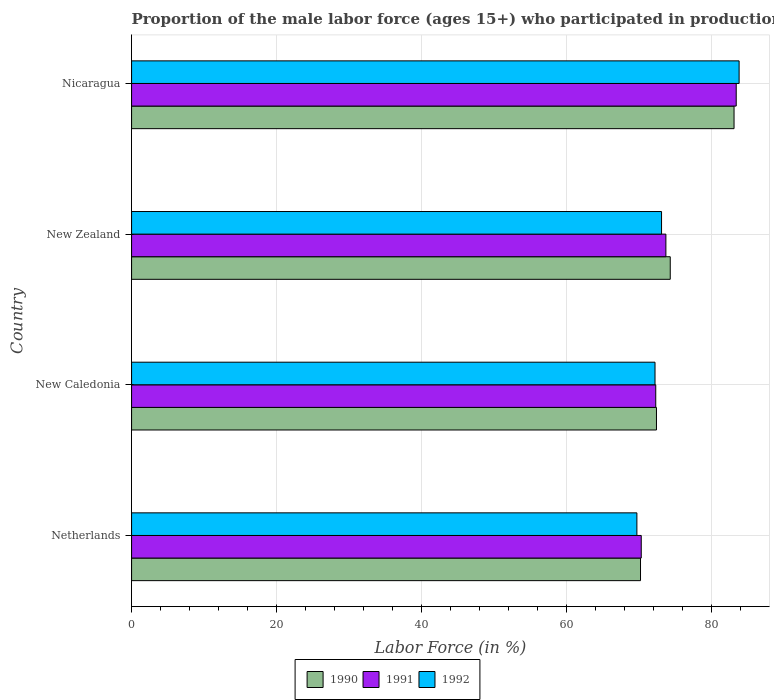How many different coloured bars are there?
Your answer should be very brief. 3. How many groups of bars are there?
Offer a very short reply. 4. Are the number of bars per tick equal to the number of legend labels?
Give a very brief answer. Yes. Are the number of bars on each tick of the Y-axis equal?
Provide a succinct answer. Yes. What is the label of the 2nd group of bars from the top?
Your answer should be very brief. New Zealand. What is the proportion of the male labor force who participated in production in 1992 in Netherlands?
Offer a terse response. 69.7. Across all countries, what is the maximum proportion of the male labor force who participated in production in 1992?
Your answer should be very brief. 83.8. Across all countries, what is the minimum proportion of the male labor force who participated in production in 1991?
Your response must be concise. 70.3. In which country was the proportion of the male labor force who participated in production in 1992 maximum?
Provide a short and direct response. Nicaragua. What is the total proportion of the male labor force who participated in production in 1990 in the graph?
Your answer should be compact. 300. What is the difference between the proportion of the male labor force who participated in production in 1991 in New Caledonia and that in New Zealand?
Provide a succinct answer. -1.4. What is the difference between the proportion of the male labor force who participated in production in 1991 in New Zealand and the proportion of the male labor force who participated in production in 1990 in Netherlands?
Ensure brevity in your answer.  3.5. What is the average proportion of the male labor force who participated in production in 1992 per country?
Give a very brief answer. 74.7. What is the difference between the proportion of the male labor force who participated in production in 1991 and proportion of the male labor force who participated in production in 1992 in New Caledonia?
Your response must be concise. 0.1. In how many countries, is the proportion of the male labor force who participated in production in 1992 greater than 12 %?
Provide a succinct answer. 4. What is the ratio of the proportion of the male labor force who participated in production in 1992 in New Zealand to that in Nicaragua?
Your response must be concise. 0.87. Is the proportion of the male labor force who participated in production in 1990 in Netherlands less than that in New Caledonia?
Your answer should be compact. Yes. Is the difference between the proportion of the male labor force who participated in production in 1991 in New Caledonia and Nicaragua greater than the difference between the proportion of the male labor force who participated in production in 1992 in New Caledonia and Nicaragua?
Your answer should be compact. Yes. What is the difference between the highest and the second highest proportion of the male labor force who participated in production in 1991?
Keep it short and to the point. 9.7. What is the difference between the highest and the lowest proportion of the male labor force who participated in production in 1992?
Provide a short and direct response. 14.1. What does the 2nd bar from the bottom in Netherlands represents?
Your answer should be very brief. 1991. How many bars are there?
Your response must be concise. 12. How many countries are there in the graph?
Give a very brief answer. 4. What is the difference between two consecutive major ticks on the X-axis?
Your answer should be very brief. 20. Does the graph contain grids?
Provide a short and direct response. Yes. How are the legend labels stacked?
Your response must be concise. Horizontal. What is the title of the graph?
Offer a very short reply. Proportion of the male labor force (ages 15+) who participated in production. Does "1976" appear as one of the legend labels in the graph?
Ensure brevity in your answer.  No. What is the label or title of the Y-axis?
Your response must be concise. Country. What is the Labor Force (in %) of 1990 in Netherlands?
Give a very brief answer. 70.2. What is the Labor Force (in %) of 1991 in Netherlands?
Keep it short and to the point. 70.3. What is the Labor Force (in %) in 1992 in Netherlands?
Ensure brevity in your answer.  69.7. What is the Labor Force (in %) in 1990 in New Caledonia?
Offer a very short reply. 72.4. What is the Labor Force (in %) in 1991 in New Caledonia?
Keep it short and to the point. 72.3. What is the Labor Force (in %) in 1992 in New Caledonia?
Your response must be concise. 72.2. What is the Labor Force (in %) of 1990 in New Zealand?
Provide a short and direct response. 74.3. What is the Labor Force (in %) of 1991 in New Zealand?
Provide a short and direct response. 73.7. What is the Labor Force (in %) of 1992 in New Zealand?
Offer a very short reply. 73.1. What is the Labor Force (in %) of 1990 in Nicaragua?
Give a very brief answer. 83.1. What is the Labor Force (in %) of 1991 in Nicaragua?
Your answer should be compact. 83.4. What is the Labor Force (in %) in 1992 in Nicaragua?
Provide a short and direct response. 83.8. Across all countries, what is the maximum Labor Force (in %) of 1990?
Your answer should be compact. 83.1. Across all countries, what is the maximum Labor Force (in %) in 1991?
Make the answer very short. 83.4. Across all countries, what is the maximum Labor Force (in %) of 1992?
Provide a succinct answer. 83.8. Across all countries, what is the minimum Labor Force (in %) of 1990?
Provide a succinct answer. 70.2. Across all countries, what is the minimum Labor Force (in %) in 1991?
Your response must be concise. 70.3. Across all countries, what is the minimum Labor Force (in %) of 1992?
Offer a terse response. 69.7. What is the total Labor Force (in %) in 1990 in the graph?
Offer a very short reply. 300. What is the total Labor Force (in %) of 1991 in the graph?
Your answer should be compact. 299.7. What is the total Labor Force (in %) of 1992 in the graph?
Offer a very short reply. 298.8. What is the difference between the Labor Force (in %) of 1990 in Netherlands and that in New Caledonia?
Provide a succinct answer. -2.2. What is the difference between the Labor Force (in %) in 1991 in Netherlands and that in New Caledonia?
Your answer should be very brief. -2. What is the difference between the Labor Force (in %) in 1990 in Netherlands and that in New Zealand?
Give a very brief answer. -4.1. What is the difference between the Labor Force (in %) of 1992 in Netherlands and that in New Zealand?
Make the answer very short. -3.4. What is the difference between the Labor Force (in %) in 1990 in Netherlands and that in Nicaragua?
Your answer should be compact. -12.9. What is the difference between the Labor Force (in %) of 1991 in Netherlands and that in Nicaragua?
Your answer should be very brief. -13.1. What is the difference between the Labor Force (in %) in 1992 in Netherlands and that in Nicaragua?
Ensure brevity in your answer.  -14.1. What is the difference between the Labor Force (in %) of 1992 in New Caledonia and that in New Zealand?
Make the answer very short. -0.9. What is the difference between the Labor Force (in %) in 1991 in New Caledonia and that in Nicaragua?
Ensure brevity in your answer.  -11.1. What is the difference between the Labor Force (in %) in 1990 in New Zealand and that in Nicaragua?
Make the answer very short. -8.8. What is the difference between the Labor Force (in %) of 1992 in New Zealand and that in Nicaragua?
Offer a very short reply. -10.7. What is the difference between the Labor Force (in %) of 1990 in Netherlands and the Labor Force (in %) of 1991 in New Caledonia?
Give a very brief answer. -2.1. What is the difference between the Labor Force (in %) of 1990 in Netherlands and the Labor Force (in %) of 1991 in New Zealand?
Keep it short and to the point. -3.5. What is the difference between the Labor Force (in %) of 1990 in Netherlands and the Labor Force (in %) of 1992 in New Zealand?
Make the answer very short. -2.9. What is the difference between the Labor Force (in %) of 1991 in Netherlands and the Labor Force (in %) of 1992 in New Zealand?
Provide a short and direct response. -2.8. What is the difference between the Labor Force (in %) of 1990 in Netherlands and the Labor Force (in %) of 1991 in Nicaragua?
Give a very brief answer. -13.2. What is the difference between the Labor Force (in %) in 1990 in Netherlands and the Labor Force (in %) in 1992 in Nicaragua?
Provide a succinct answer. -13.6. What is the difference between the Labor Force (in %) of 1990 in New Caledonia and the Labor Force (in %) of 1991 in Nicaragua?
Offer a very short reply. -11. What is the difference between the Labor Force (in %) of 1990 in New Zealand and the Labor Force (in %) of 1992 in Nicaragua?
Provide a succinct answer. -9.5. What is the difference between the Labor Force (in %) of 1991 in New Zealand and the Labor Force (in %) of 1992 in Nicaragua?
Your answer should be very brief. -10.1. What is the average Labor Force (in %) in 1990 per country?
Make the answer very short. 75. What is the average Labor Force (in %) of 1991 per country?
Keep it short and to the point. 74.92. What is the average Labor Force (in %) in 1992 per country?
Offer a terse response. 74.7. What is the difference between the Labor Force (in %) of 1991 and Labor Force (in %) of 1992 in Netherlands?
Make the answer very short. 0.6. What is the difference between the Labor Force (in %) of 1990 and Labor Force (in %) of 1991 in New Caledonia?
Your response must be concise. 0.1. What is the difference between the Labor Force (in %) in 1990 and Labor Force (in %) in 1992 in New Caledonia?
Give a very brief answer. 0.2. What is the difference between the Labor Force (in %) of 1990 and Labor Force (in %) of 1991 in New Zealand?
Ensure brevity in your answer.  0.6. What is the difference between the Labor Force (in %) of 1990 and Labor Force (in %) of 1991 in Nicaragua?
Keep it short and to the point. -0.3. What is the ratio of the Labor Force (in %) of 1990 in Netherlands to that in New Caledonia?
Make the answer very short. 0.97. What is the ratio of the Labor Force (in %) of 1991 in Netherlands to that in New Caledonia?
Your response must be concise. 0.97. What is the ratio of the Labor Force (in %) in 1992 in Netherlands to that in New Caledonia?
Make the answer very short. 0.97. What is the ratio of the Labor Force (in %) of 1990 in Netherlands to that in New Zealand?
Your answer should be compact. 0.94. What is the ratio of the Labor Force (in %) of 1991 in Netherlands to that in New Zealand?
Your response must be concise. 0.95. What is the ratio of the Labor Force (in %) of 1992 in Netherlands to that in New Zealand?
Your answer should be compact. 0.95. What is the ratio of the Labor Force (in %) of 1990 in Netherlands to that in Nicaragua?
Provide a short and direct response. 0.84. What is the ratio of the Labor Force (in %) of 1991 in Netherlands to that in Nicaragua?
Provide a short and direct response. 0.84. What is the ratio of the Labor Force (in %) in 1992 in Netherlands to that in Nicaragua?
Give a very brief answer. 0.83. What is the ratio of the Labor Force (in %) in 1990 in New Caledonia to that in New Zealand?
Offer a terse response. 0.97. What is the ratio of the Labor Force (in %) of 1992 in New Caledonia to that in New Zealand?
Make the answer very short. 0.99. What is the ratio of the Labor Force (in %) of 1990 in New Caledonia to that in Nicaragua?
Give a very brief answer. 0.87. What is the ratio of the Labor Force (in %) of 1991 in New Caledonia to that in Nicaragua?
Offer a terse response. 0.87. What is the ratio of the Labor Force (in %) in 1992 in New Caledonia to that in Nicaragua?
Give a very brief answer. 0.86. What is the ratio of the Labor Force (in %) of 1990 in New Zealand to that in Nicaragua?
Your answer should be compact. 0.89. What is the ratio of the Labor Force (in %) of 1991 in New Zealand to that in Nicaragua?
Give a very brief answer. 0.88. What is the ratio of the Labor Force (in %) of 1992 in New Zealand to that in Nicaragua?
Your response must be concise. 0.87. What is the difference between the highest and the second highest Labor Force (in %) of 1990?
Your answer should be very brief. 8.8. What is the difference between the highest and the lowest Labor Force (in %) of 1992?
Make the answer very short. 14.1. 